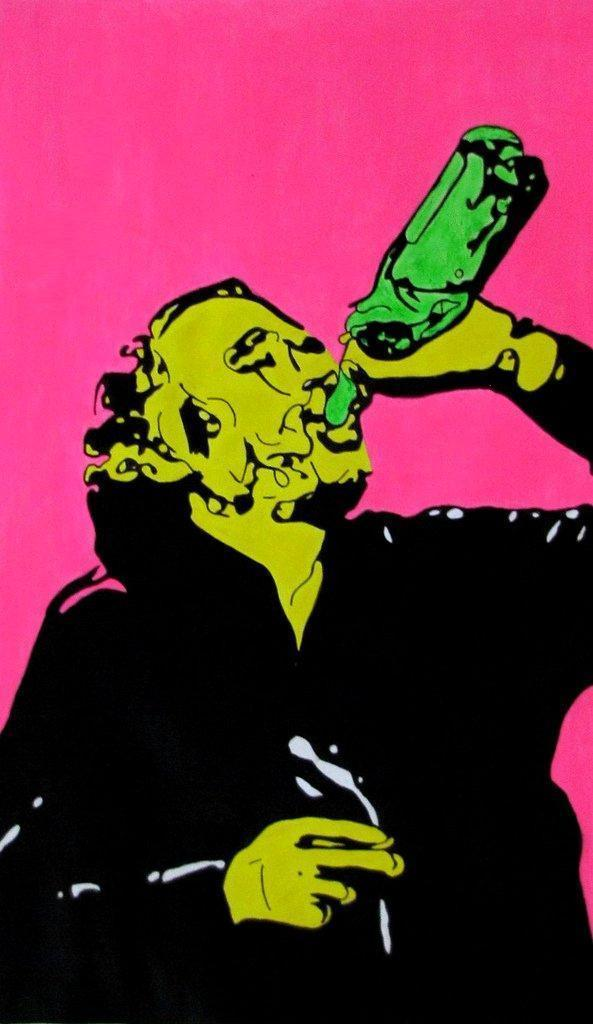What is the main subject of the image? There is a person depicted in the image. What is the person holding in his hand? The person is holding a bottle in his hand. What can be seen in the background of the image? There is a pink wall in the background of the image. How many cherries are on the shelf in the image? There is no shelf or cherries present in the image. What type of bridge can be seen in the background of the image? There is no bridge present in the image; it features a person holding a bottle in front of a pink wall. 